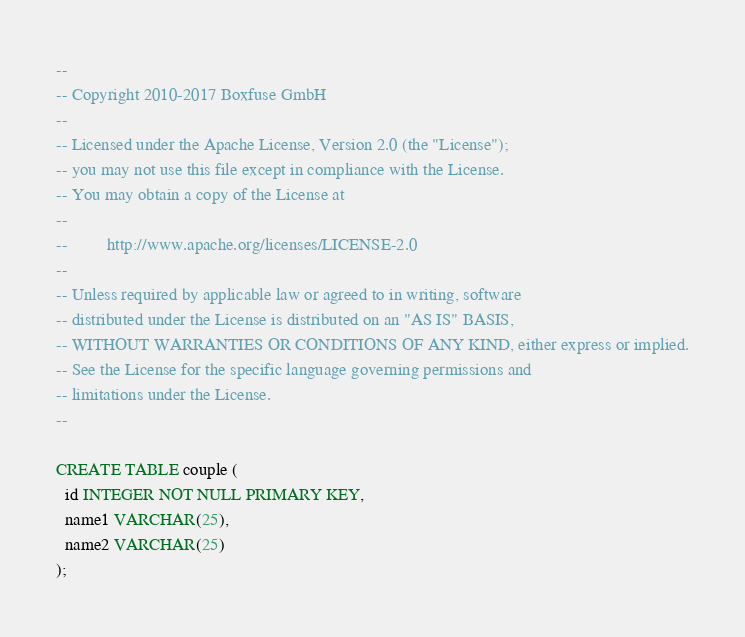Convert code to text. <code><loc_0><loc_0><loc_500><loc_500><_SQL_>--
-- Copyright 2010-2017 Boxfuse GmbH
--
-- Licensed under the Apache License, Version 2.0 (the "License");
-- you may not use this file except in compliance with the License.
-- You may obtain a copy of the License at
--
--         http://www.apache.org/licenses/LICENSE-2.0
--
-- Unless required by applicable law or agreed to in writing, software
-- distributed under the License is distributed on an "AS IS" BASIS,
-- WITHOUT WARRANTIES OR CONDITIONS OF ANY KIND, either express or implied.
-- See the License for the specific language governing permissions and
-- limitations under the License.
--

CREATE TABLE couple (
  id INTEGER NOT NULL PRIMARY KEY,
  name1 VARCHAR(25),
  name2 VARCHAR(25)
);
</code> 